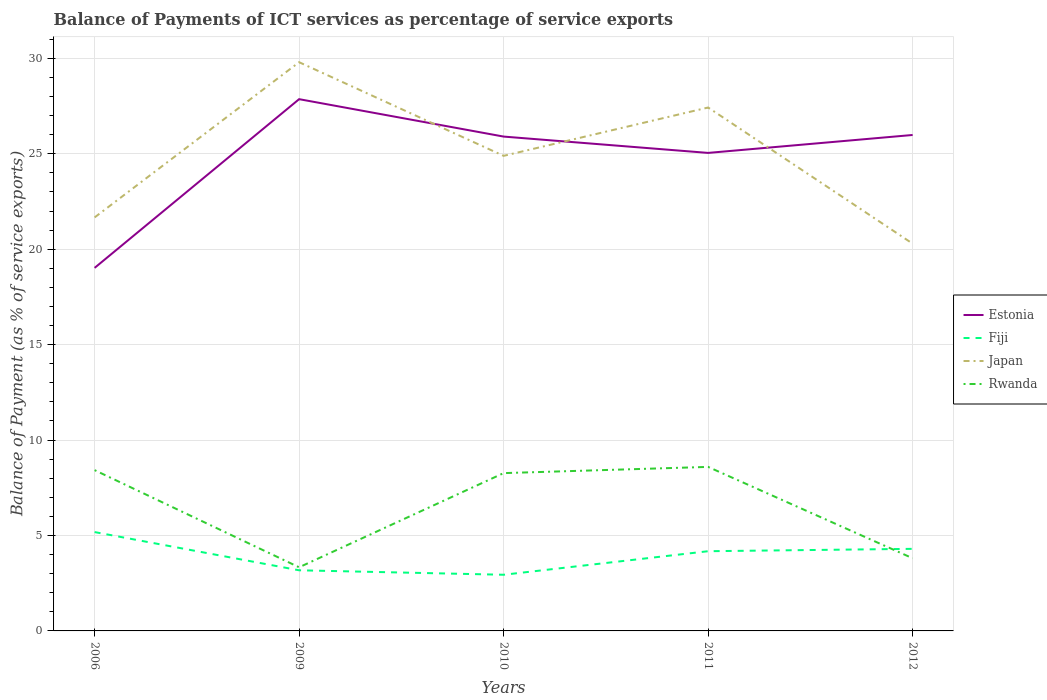Does the line corresponding to Estonia intersect with the line corresponding to Japan?
Provide a short and direct response. Yes. Across all years, what is the maximum balance of payments of ICT services in Japan?
Keep it short and to the point. 20.29. In which year was the balance of payments of ICT services in Japan maximum?
Give a very brief answer. 2012. What is the total balance of payments of ICT services in Rwanda in the graph?
Offer a very short reply. -4.93. What is the difference between the highest and the second highest balance of payments of ICT services in Rwanda?
Your answer should be very brief. 5.26. Is the balance of payments of ICT services in Japan strictly greater than the balance of payments of ICT services in Fiji over the years?
Your response must be concise. No. How many lines are there?
Your answer should be very brief. 4. How many years are there in the graph?
Ensure brevity in your answer.  5. What is the difference between two consecutive major ticks on the Y-axis?
Keep it short and to the point. 5. Are the values on the major ticks of Y-axis written in scientific E-notation?
Make the answer very short. No. Where does the legend appear in the graph?
Your answer should be compact. Center right. What is the title of the graph?
Give a very brief answer. Balance of Payments of ICT services as percentage of service exports. What is the label or title of the Y-axis?
Your answer should be very brief. Balance of Payment (as % of service exports). What is the Balance of Payment (as % of service exports) of Estonia in 2006?
Provide a short and direct response. 19.02. What is the Balance of Payment (as % of service exports) of Fiji in 2006?
Give a very brief answer. 5.18. What is the Balance of Payment (as % of service exports) of Japan in 2006?
Offer a terse response. 21.67. What is the Balance of Payment (as % of service exports) in Rwanda in 2006?
Ensure brevity in your answer.  8.42. What is the Balance of Payment (as % of service exports) of Estonia in 2009?
Provide a succinct answer. 27.86. What is the Balance of Payment (as % of service exports) of Fiji in 2009?
Provide a succinct answer. 3.18. What is the Balance of Payment (as % of service exports) in Japan in 2009?
Provide a short and direct response. 29.8. What is the Balance of Payment (as % of service exports) of Rwanda in 2009?
Make the answer very short. 3.33. What is the Balance of Payment (as % of service exports) in Estonia in 2010?
Make the answer very short. 25.9. What is the Balance of Payment (as % of service exports) in Fiji in 2010?
Your answer should be compact. 2.94. What is the Balance of Payment (as % of service exports) of Japan in 2010?
Provide a succinct answer. 24.89. What is the Balance of Payment (as % of service exports) of Rwanda in 2010?
Your answer should be very brief. 8.27. What is the Balance of Payment (as % of service exports) in Estonia in 2011?
Ensure brevity in your answer.  25.05. What is the Balance of Payment (as % of service exports) in Fiji in 2011?
Offer a very short reply. 4.18. What is the Balance of Payment (as % of service exports) in Japan in 2011?
Offer a very short reply. 27.42. What is the Balance of Payment (as % of service exports) of Rwanda in 2011?
Your answer should be very brief. 8.59. What is the Balance of Payment (as % of service exports) in Estonia in 2012?
Your answer should be very brief. 25.99. What is the Balance of Payment (as % of service exports) in Fiji in 2012?
Provide a short and direct response. 4.3. What is the Balance of Payment (as % of service exports) of Japan in 2012?
Your answer should be very brief. 20.29. What is the Balance of Payment (as % of service exports) of Rwanda in 2012?
Ensure brevity in your answer.  3.81. Across all years, what is the maximum Balance of Payment (as % of service exports) of Estonia?
Keep it short and to the point. 27.86. Across all years, what is the maximum Balance of Payment (as % of service exports) in Fiji?
Provide a succinct answer. 5.18. Across all years, what is the maximum Balance of Payment (as % of service exports) in Japan?
Your answer should be very brief. 29.8. Across all years, what is the maximum Balance of Payment (as % of service exports) of Rwanda?
Your answer should be very brief. 8.59. Across all years, what is the minimum Balance of Payment (as % of service exports) in Estonia?
Keep it short and to the point. 19.02. Across all years, what is the minimum Balance of Payment (as % of service exports) of Fiji?
Your answer should be compact. 2.94. Across all years, what is the minimum Balance of Payment (as % of service exports) in Japan?
Your answer should be very brief. 20.29. Across all years, what is the minimum Balance of Payment (as % of service exports) in Rwanda?
Provide a short and direct response. 3.33. What is the total Balance of Payment (as % of service exports) of Estonia in the graph?
Give a very brief answer. 123.82. What is the total Balance of Payment (as % of service exports) of Fiji in the graph?
Keep it short and to the point. 19.78. What is the total Balance of Payment (as % of service exports) in Japan in the graph?
Provide a short and direct response. 124.07. What is the total Balance of Payment (as % of service exports) of Rwanda in the graph?
Your answer should be compact. 32.43. What is the difference between the Balance of Payment (as % of service exports) in Estonia in 2006 and that in 2009?
Give a very brief answer. -8.84. What is the difference between the Balance of Payment (as % of service exports) in Fiji in 2006 and that in 2009?
Your response must be concise. 2. What is the difference between the Balance of Payment (as % of service exports) in Japan in 2006 and that in 2009?
Ensure brevity in your answer.  -8.13. What is the difference between the Balance of Payment (as % of service exports) in Rwanda in 2006 and that in 2009?
Offer a very short reply. 5.09. What is the difference between the Balance of Payment (as % of service exports) in Estonia in 2006 and that in 2010?
Make the answer very short. -6.88. What is the difference between the Balance of Payment (as % of service exports) of Fiji in 2006 and that in 2010?
Your response must be concise. 2.24. What is the difference between the Balance of Payment (as % of service exports) of Japan in 2006 and that in 2010?
Provide a succinct answer. -3.23. What is the difference between the Balance of Payment (as % of service exports) of Rwanda in 2006 and that in 2010?
Your answer should be compact. 0.16. What is the difference between the Balance of Payment (as % of service exports) in Estonia in 2006 and that in 2011?
Keep it short and to the point. -6.02. What is the difference between the Balance of Payment (as % of service exports) of Japan in 2006 and that in 2011?
Ensure brevity in your answer.  -5.76. What is the difference between the Balance of Payment (as % of service exports) of Rwanda in 2006 and that in 2011?
Offer a terse response. -0.17. What is the difference between the Balance of Payment (as % of service exports) of Estonia in 2006 and that in 2012?
Make the answer very short. -6.96. What is the difference between the Balance of Payment (as % of service exports) of Fiji in 2006 and that in 2012?
Make the answer very short. 0.88. What is the difference between the Balance of Payment (as % of service exports) in Japan in 2006 and that in 2012?
Ensure brevity in your answer.  1.37. What is the difference between the Balance of Payment (as % of service exports) of Rwanda in 2006 and that in 2012?
Your response must be concise. 4.62. What is the difference between the Balance of Payment (as % of service exports) of Estonia in 2009 and that in 2010?
Your response must be concise. 1.96. What is the difference between the Balance of Payment (as % of service exports) of Fiji in 2009 and that in 2010?
Your answer should be very brief. 0.23. What is the difference between the Balance of Payment (as % of service exports) of Japan in 2009 and that in 2010?
Keep it short and to the point. 4.91. What is the difference between the Balance of Payment (as % of service exports) in Rwanda in 2009 and that in 2010?
Offer a terse response. -4.93. What is the difference between the Balance of Payment (as % of service exports) of Estonia in 2009 and that in 2011?
Your answer should be very brief. 2.82. What is the difference between the Balance of Payment (as % of service exports) in Fiji in 2009 and that in 2011?
Offer a very short reply. -1. What is the difference between the Balance of Payment (as % of service exports) of Japan in 2009 and that in 2011?
Make the answer very short. 2.37. What is the difference between the Balance of Payment (as % of service exports) of Rwanda in 2009 and that in 2011?
Provide a succinct answer. -5.26. What is the difference between the Balance of Payment (as % of service exports) of Estonia in 2009 and that in 2012?
Ensure brevity in your answer.  1.88. What is the difference between the Balance of Payment (as % of service exports) of Fiji in 2009 and that in 2012?
Offer a terse response. -1.12. What is the difference between the Balance of Payment (as % of service exports) of Japan in 2009 and that in 2012?
Your response must be concise. 9.51. What is the difference between the Balance of Payment (as % of service exports) in Rwanda in 2009 and that in 2012?
Keep it short and to the point. -0.47. What is the difference between the Balance of Payment (as % of service exports) of Estonia in 2010 and that in 2011?
Your answer should be very brief. 0.86. What is the difference between the Balance of Payment (as % of service exports) in Fiji in 2010 and that in 2011?
Provide a short and direct response. -1.23. What is the difference between the Balance of Payment (as % of service exports) of Japan in 2010 and that in 2011?
Make the answer very short. -2.53. What is the difference between the Balance of Payment (as % of service exports) of Rwanda in 2010 and that in 2011?
Your answer should be very brief. -0.33. What is the difference between the Balance of Payment (as % of service exports) of Estonia in 2010 and that in 2012?
Provide a short and direct response. -0.08. What is the difference between the Balance of Payment (as % of service exports) in Fiji in 2010 and that in 2012?
Your answer should be compact. -1.36. What is the difference between the Balance of Payment (as % of service exports) of Japan in 2010 and that in 2012?
Ensure brevity in your answer.  4.6. What is the difference between the Balance of Payment (as % of service exports) in Rwanda in 2010 and that in 2012?
Offer a terse response. 4.46. What is the difference between the Balance of Payment (as % of service exports) in Estonia in 2011 and that in 2012?
Your answer should be compact. -0.94. What is the difference between the Balance of Payment (as % of service exports) in Fiji in 2011 and that in 2012?
Make the answer very short. -0.12. What is the difference between the Balance of Payment (as % of service exports) in Japan in 2011 and that in 2012?
Provide a succinct answer. 7.13. What is the difference between the Balance of Payment (as % of service exports) of Rwanda in 2011 and that in 2012?
Give a very brief answer. 4.79. What is the difference between the Balance of Payment (as % of service exports) of Estonia in 2006 and the Balance of Payment (as % of service exports) of Fiji in 2009?
Offer a terse response. 15.84. What is the difference between the Balance of Payment (as % of service exports) of Estonia in 2006 and the Balance of Payment (as % of service exports) of Japan in 2009?
Your answer should be compact. -10.78. What is the difference between the Balance of Payment (as % of service exports) of Estonia in 2006 and the Balance of Payment (as % of service exports) of Rwanda in 2009?
Your answer should be very brief. 15.69. What is the difference between the Balance of Payment (as % of service exports) in Fiji in 2006 and the Balance of Payment (as % of service exports) in Japan in 2009?
Provide a short and direct response. -24.62. What is the difference between the Balance of Payment (as % of service exports) in Fiji in 2006 and the Balance of Payment (as % of service exports) in Rwanda in 2009?
Make the answer very short. 1.84. What is the difference between the Balance of Payment (as % of service exports) of Japan in 2006 and the Balance of Payment (as % of service exports) of Rwanda in 2009?
Offer a terse response. 18.33. What is the difference between the Balance of Payment (as % of service exports) of Estonia in 2006 and the Balance of Payment (as % of service exports) of Fiji in 2010?
Your answer should be very brief. 16.08. What is the difference between the Balance of Payment (as % of service exports) in Estonia in 2006 and the Balance of Payment (as % of service exports) in Japan in 2010?
Provide a succinct answer. -5.87. What is the difference between the Balance of Payment (as % of service exports) in Estonia in 2006 and the Balance of Payment (as % of service exports) in Rwanda in 2010?
Make the answer very short. 10.75. What is the difference between the Balance of Payment (as % of service exports) of Fiji in 2006 and the Balance of Payment (as % of service exports) of Japan in 2010?
Offer a terse response. -19.71. What is the difference between the Balance of Payment (as % of service exports) in Fiji in 2006 and the Balance of Payment (as % of service exports) in Rwanda in 2010?
Offer a terse response. -3.09. What is the difference between the Balance of Payment (as % of service exports) in Japan in 2006 and the Balance of Payment (as % of service exports) in Rwanda in 2010?
Your answer should be compact. 13.4. What is the difference between the Balance of Payment (as % of service exports) in Estonia in 2006 and the Balance of Payment (as % of service exports) in Fiji in 2011?
Keep it short and to the point. 14.84. What is the difference between the Balance of Payment (as % of service exports) in Estonia in 2006 and the Balance of Payment (as % of service exports) in Japan in 2011?
Provide a short and direct response. -8.4. What is the difference between the Balance of Payment (as % of service exports) in Estonia in 2006 and the Balance of Payment (as % of service exports) in Rwanda in 2011?
Provide a succinct answer. 10.43. What is the difference between the Balance of Payment (as % of service exports) of Fiji in 2006 and the Balance of Payment (as % of service exports) of Japan in 2011?
Offer a terse response. -22.25. What is the difference between the Balance of Payment (as % of service exports) of Fiji in 2006 and the Balance of Payment (as % of service exports) of Rwanda in 2011?
Your answer should be very brief. -3.42. What is the difference between the Balance of Payment (as % of service exports) in Japan in 2006 and the Balance of Payment (as % of service exports) in Rwanda in 2011?
Make the answer very short. 13.07. What is the difference between the Balance of Payment (as % of service exports) of Estonia in 2006 and the Balance of Payment (as % of service exports) of Fiji in 2012?
Your answer should be very brief. 14.72. What is the difference between the Balance of Payment (as % of service exports) of Estonia in 2006 and the Balance of Payment (as % of service exports) of Japan in 2012?
Keep it short and to the point. -1.27. What is the difference between the Balance of Payment (as % of service exports) of Estonia in 2006 and the Balance of Payment (as % of service exports) of Rwanda in 2012?
Your answer should be compact. 15.21. What is the difference between the Balance of Payment (as % of service exports) of Fiji in 2006 and the Balance of Payment (as % of service exports) of Japan in 2012?
Offer a very short reply. -15.11. What is the difference between the Balance of Payment (as % of service exports) in Fiji in 2006 and the Balance of Payment (as % of service exports) in Rwanda in 2012?
Provide a succinct answer. 1.37. What is the difference between the Balance of Payment (as % of service exports) of Japan in 2006 and the Balance of Payment (as % of service exports) of Rwanda in 2012?
Ensure brevity in your answer.  17.86. What is the difference between the Balance of Payment (as % of service exports) in Estonia in 2009 and the Balance of Payment (as % of service exports) in Fiji in 2010?
Ensure brevity in your answer.  24.92. What is the difference between the Balance of Payment (as % of service exports) in Estonia in 2009 and the Balance of Payment (as % of service exports) in Japan in 2010?
Your response must be concise. 2.97. What is the difference between the Balance of Payment (as % of service exports) of Estonia in 2009 and the Balance of Payment (as % of service exports) of Rwanda in 2010?
Offer a very short reply. 19.59. What is the difference between the Balance of Payment (as % of service exports) in Fiji in 2009 and the Balance of Payment (as % of service exports) in Japan in 2010?
Give a very brief answer. -21.71. What is the difference between the Balance of Payment (as % of service exports) of Fiji in 2009 and the Balance of Payment (as % of service exports) of Rwanda in 2010?
Ensure brevity in your answer.  -5.09. What is the difference between the Balance of Payment (as % of service exports) in Japan in 2009 and the Balance of Payment (as % of service exports) in Rwanda in 2010?
Your answer should be very brief. 21.53. What is the difference between the Balance of Payment (as % of service exports) in Estonia in 2009 and the Balance of Payment (as % of service exports) in Fiji in 2011?
Keep it short and to the point. 23.68. What is the difference between the Balance of Payment (as % of service exports) in Estonia in 2009 and the Balance of Payment (as % of service exports) in Japan in 2011?
Provide a short and direct response. 0.44. What is the difference between the Balance of Payment (as % of service exports) of Estonia in 2009 and the Balance of Payment (as % of service exports) of Rwanda in 2011?
Offer a terse response. 19.27. What is the difference between the Balance of Payment (as % of service exports) in Fiji in 2009 and the Balance of Payment (as % of service exports) in Japan in 2011?
Provide a succinct answer. -24.25. What is the difference between the Balance of Payment (as % of service exports) of Fiji in 2009 and the Balance of Payment (as % of service exports) of Rwanda in 2011?
Ensure brevity in your answer.  -5.42. What is the difference between the Balance of Payment (as % of service exports) of Japan in 2009 and the Balance of Payment (as % of service exports) of Rwanda in 2011?
Your response must be concise. 21.2. What is the difference between the Balance of Payment (as % of service exports) in Estonia in 2009 and the Balance of Payment (as % of service exports) in Fiji in 2012?
Offer a very short reply. 23.56. What is the difference between the Balance of Payment (as % of service exports) of Estonia in 2009 and the Balance of Payment (as % of service exports) of Japan in 2012?
Your answer should be very brief. 7.57. What is the difference between the Balance of Payment (as % of service exports) in Estonia in 2009 and the Balance of Payment (as % of service exports) in Rwanda in 2012?
Give a very brief answer. 24.05. What is the difference between the Balance of Payment (as % of service exports) in Fiji in 2009 and the Balance of Payment (as % of service exports) in Japan in 2012?
Offer a terse response. -17.12. What is the difference between the Balance of Payment (as % of service exports) of Fiji in 2009 and the Balance of Payment (as % of service exports) of Rwanda in 2012?
Make the answer very short. -0.63. What is the difference between the Balance of Payment (as % of service exports) in Japan in 2009 and the Balance of Payment (as % of service exports) in Rwanda in 2012?
Keep it short and to the point. 25.99. What is the difference between the Balance of Payment (as % of service exports) in Estonia in 2010 and the Balance of Payment (as % of service exports) in Fiji in 2011?
Give a very brief answer. 21.72. What is the difference between the Balance of Payment (as % of service exports) in Estonia in 2010 and the Balance of Payment (as % of service exports) in Japan in 2011?
Keep it short and to the point. -1.52. What is the difference between the Balance of Payment (as % of service exports) of Estonia in 2010 and the Balance of Payment (as % of service exports) of Rwanda in 2011?
Your response must be concise. 17.31. What is the difference between the Balance of Payment (as % of service exports) of Fiji in 2010 and the Balance of Payment (as % of service exports) of Japan in 2011?
Your response must be concise. -24.48. What is the difference between the Balance of Payment (as % of service exports) of Fiji in 2010 and the Balance of Payment (as % of service exports) of Rwanda in 2011?
Provide a succinct answer. -5.65. What is the difference between the Balance of Payment (as % of service exports) of Japan in 2010 and the Balance of Payment (as % of service exports) of Rwanda in 2011?
Give a very brief answer. 16.3. What is the difference between the Balance of Payment (as % of service exports) of Estonia in 2010 and the Balance of Payment (as % of service exports) of Fiji in 2012?
Your answer should be very brief. 21.6. What is the difference between the Balance of Payment (as % of service exports) of Estonia in 2010 and the Balance of Payment (as % of service exports) of Japan in 2012?
Offer a very short reply. 5.61. What is the difference between the Balance of Payment (as % of service exports) of Estonia in 2010 and the Balance of Payment (as % of service exports) of Rwanda in 2012?
Provide a short and direct response. 22.09. What is the difference between the Balance of Payment (as % of service exports) in Fiji in 2010 and the Balance of Payment (as % of service exports) in Japan in 2012?
Your answer should be very brief. -17.35. What is the difference between the Balance of Payment (as % of service exports) of Fiji in 2010 and the Balance of Payment (as % of service exports) of Rwanda in 2012?
Provide a succinct answer. -0.86. What is the difference between the Balance of Payment (as % of service exports) in Japan in 2010 and the Balance of Payment (as % of service exports) in Rwanda in 2012?
Your answer should be compact. 21.08. What is the difference between the Balance of Payment (as % of service exports) of Estonia in 2011 and the Balance of Payment (as % of service exports) of Fiji in 2012?
Provide a succinct answer. 20.75. What is the difference between the Balance of Payment (as % of service exports) of Estonia in 2011 and the Balance of Payment (as % of service exports) of Japan in 2012?
Provide a succinct answer. 4.75. What is the difference between the Balance of Payment (as % of service exports) of Estonia in 2011 and the Balance of Payment (as % of service exports) of Rwanda in 2012?
Offer a very short reply. 21.24. What is the difference between the Balance of Payment (as % of service exports) in Fiji in 2011 and the Balance of Payment (as % of service exports) in Japan in 2012?
Offer a very short reply. -16.12. What is the difference between the Balance of Payment (as % of service exports) in Fiji in 2011 and the Balance of Payment (as % of service exports) in Rwanda in 2012?
Offer a terse response. 0.37. What is the difference between the Balance of Payment (as % of service exports) in Japan in 2011 and the Balance of Payment (as % of service exports) in Rwanda in 2012?
Your answer should be compact. 23.62. What is the average Balance of Payment (as % of service exports) of Estonia per year?
Offer a terse response. 24.76. What is the average Balance of Payment (as % of service exports) of Fiji per year?
Provide a short and direct response. 3.96. What is the average Balance of Payment (as % of service exports) in Japan per year?
Make the answer very short. 24.81. What is the average Balance of Payment (as % of service exports) of Rwanda per year?
Offer a very short reply. 6.49. In the year 2006, what is the difference between the Balance of Payment (as % of service exports) of Estonia and Balance of Payment (as % of service exports) of Fiji?
Offer a very short reply. 13.84. In the year 2006, what is the difference between the Balance of Payment (as % of service exports) in Estonia and Balance of Payment (as % of service exports) in Japan?
Your answer should be compact. -2.65. In the year 2006, what is the difference between the Balance of Payment (as % of service exports) in Estonia and Balance of Payment (as % of service exports) in Rwanda?
Ensure brevity in your answer.  10.6. In the year 2006, what is the difference between the Balance of Payment (as % of service exports) in Fiji and Balance of Payment (as % of service exports) in Japan?
Provide a short and direct response. -16.49. In the year 2006, what is the difference between the Balance of Payment (as % of service exports) of Fiji and Balance of Payment (as % of service exports) of Rwanda?
Offer a terse response. -3.25. In the year 2006, what is the difference between the Balance of Payment (as % of service exports) of Japan and Balance of Payment (as % of service exports) of Rwanda?
Make the answer very short. 13.24. In the year 2009, what is the difference between the Balance of Payment (as % of service exports) of Estonia and Balance of Payment (as % of service exports) of Fiji?
Offer a very short reply. 24.68. In the year 2009, what is the difference between the Balance of Payment (as % of service exports) in Estonia and Balance of Payment (as % of service exports) in Japan?
Offer a terse response. -1.94. In the year 2009, what is the difference between the Balance of Payment (as % of service exports) in Estonia and Balance of Payment (as % of service exports) in Rwanda?
Your response must be concise. 24.53. In the year 2009, what is the difference between the Balance of Payment (as % of service exports) in Fiji and Balance of Payment (as % of service exports) in Japan?
Offer a terse response. -26.62. In the year 2009, what is the difference between the Balance of Payment (as % of service exports) in Fiji and Balance of Payment (as % of service exports) in Rwanda?
Make the answer very short. -0.16. In the year 2009, what is the difference between the Balance of Payment (as % of service exports) of Japan and Balance of Payment (as % of service exports) of Rwanda?
Your response must be concise. 26.46. In the year 2010, what is the difference between the Balance of Payment (as % of service exports) of Estonia and Balance of Payment (as % of service exports) of Fiji?
Provide a short and direct response. 22.96. In the year 2010, what is the difference between the Balance of Payment (as % of service exports) of Estonia and Balance of Payment (as % of service exports) of Japan?
Give a very brief answer. 1.01. In the year 2010, what is the difference between the Balance of Payment (as % of service exports) of Estonia and Balance of Payment (as % of service exports) of Rwanda?
Your answer should be compact. 17.63. In the year 2010, what is the difference between the Balance of Payment (as % of service exports) in Fiji and Balance of Payment (as % of service exports) in Japan?
Keep it short and to the point. -21.95. In the year 2010, what is the difference between the Balance of Payment (as % of service exports) in Fiji and Balance of Payment (as % of service exports) in Rwanda?
Your answer should be very brief. -5.33. In the year 2010, what is the difference between the Balance of Payment (as % of service exports) in Japan and Balance of Payment (as % of service exports) in Rwanda?
Make the answer very short. 16.62. In the year 2011, what is the difference between the Balance of Payment (as % of service exports) of Estonia and Balance of Payment (as % of service exports) of Fiji?
Your answer should be compact. 20.87. In the year 2011, what is the difference between the Balance of Payment (as % of service exports) in Estonia and Balance of Payment (as % of service exports) in Japan?
Your response must be concise. -2.38. In the year 2011, what is the difference between the Balance of Payment (as % of service exports) of Estonia and Balance of Payment (as % of service exports) of Rwanda?
Keep it short and to the point. 16.45. In the year 2011, what is the difference between the Balance of Payment (as % of service exports) of Fiji and Balance of Payment (as % of service exports) of Japan?
Offer a terse response. -23.25. In the year 2011, what is the difference between the Balance of Payment (as % of service exports) of Fiji and Balance of Payment (as % of service exports) of Rwanda?
Your answer should be very brief. -4.42. In the year 2011, what is the difference between the Balance of Payment (as % of service exports) in Japan and Balance of Payment (as % of service exports) in Rwanda?
Provide a succinct answer. 18.83. In the year 2012, what is the difference between the Balance of Payment (as % of service exports) in Estonia and Balance of Payment (as % of service exports) in Fiji?
Offer a terse response. 21.68. In the year 2012, what is the difference between the Balance of Payment (as % of service exports) of Estonia and Balance of Payment (as % of service exports) of Japan?
Provide a succinct answer. 5.69. In the year 2012, what is the difference between the Balance of Payment (as % of service exports) of Estonia and Balance of Payment (as % of service exports) of Rwanda?
Offer a very short reply. 22.18. In the year 2012, what is the difference between the Balance of Payment (as % of service exports) in Fiji and Balance of Payment (as % of service exports) in Japan?
Give a very brief answer. -15.99. In the year 2012, what is the difference between the Balance of Payment (as % of service exports) of Fiji and Balance of Payment (as % of service exports) of Rwanda?
Offer a very short reply. 0.49. In the year 2012, what is the difference between the Balance of Payment (as % of service exports) in Japan and Balance of Payment (as % of service exports) in Rwanda?
Ensure brevity in your answer.  16.48. What is the ratio of the Balance of Payment (as % of service exports) of Estonia in 2006 to that in 2009?
Provide a succinct answer. 0.68. What is the ratio of the Balance of Payment (as % of service exports) in Fiji in 2006 to that in 2009?
Offer a very short reply. 1.63. What is the ratio of the Balance of Payment (as % of service exports) in Japan in 2006 to that in 2009?
Provide a short and direct response. 0.73. What is the ratio of the Balance of Payment (as % of service exports) of Rwanda in 2006 to that in 2009?
Keep it short and to the point. 2.53. What is the ratio of the Balance of Payment (as % of service exports) of Estonia in 2006 to that in 2010?
Your answer should be compact. 0.73. What is the ratio of the Balance of Payment (as % of service exports) in Fiji in 2006 to that in 2010?
Provide a short and direct response. 1.76. What is the ratio of the Balance of Payment (as % of service exports) in Japan in 2006 to that in 2010?
Keep it short and to the point. 0.87. What is the ratio of the Balance of Payment (as % of service exports) of Rwanda in 2006 to that in 2010?
Your response must be concise. 1.02. What is the ratio of the Balance of Payment (as % of service exports) of Estonia in 2006 to that in 2011?
Your answer should be compact. 0.76. What is the ratio of the Balance of Payment (as % of service exports) in Fiji in 2006 to that in 2011?
Your response must be concise. 1.24. What is the ratio of the Balance of Payment (as % of service exports) of Japan in 2006 to that in 2011?
Provide a succinct answer. 0.79. What is the ratio of the Balance of Payment (as % of service exports) of Rwanda in 2006 to that in 2011?
Your answer should be compact. 0.98. What is the ratio of the Balance of Payment (as % of service exports) in Estonia in 2006 to that in 2012?
Ensure brevity in your answer.  0.73. What is the ratio of the Balance of Payment (as % of service exports) in Fiji in 2006 to that in 2012?
Your response must be concise. 1.2. What is the ratio of the Balance of Payment (as % of service exports) in Japan in 2006 to that in 2012?
Provide a short and direct response. 1.07. What is the ratio of the Balance of Payment (as % of service exports) in Rwanda in 2006 to that in 2012?
Provide a succinct answer. 2.21. What is the ratio of the Balance of Payment (as % of service exports) in Estonia in 2009 to that in 2010?
Make the answer very short. 1.08. What is the ratio of the Balance of Payment (as % of service exports) in Fiji in 2009 to that in 2010?
Make the answer very short. 1.08. What is the ratio of the Balance of Payment (as % of service exports) in Japan in 2009 to that in 2010?
Give a very brief answer. 1.2. What is the ratio of the Balance of Payment (as % of service exports) in Rwanda in 2009 to that in 2010?
Make the answer very short. 0.4. What is the ratio of the Balance of Payment (as % of service exports) of Estonia in 2009 to that in 2011?
Ensure brevity in your answer.  1.11. What is the ratio of the Balance of Payment (as % of service exports) in Fiji in 2009 to that in 2011?
Your answer should be very brief. 0.76. What is the ratio of the Balance of Payment (as % of service exports) in Japan in 2009 to that in 2011?
Ensure brevity in your answer.  1.09. What is the ratio of the Balance of Payment (as % of service exports) in Rwanda in 2009 to that in 2011?
Give a very brief answer. 0.39. What is the ratio of the Balance of Payment (as % of service exports) in Estonia in 2009 to that in 2012?
Offer a very short reply. 1.07. What is the ratio of the Balance of Payment (as % of service exports) in Fiji in 2009 to that in 2012?
Keep it short and to the point. 0.74. What is the ratio of the Balance of Payment (as % of service exports) in Japan in 2009 to that in 2012?
Your response must be concise. 1.47. What is the ratio of the Balance of Payment (as % of service exports) of Rwanda in 2009 to that in 2012?
Keep it short and to the point. 0.88. What is the ratio of the Balance of Payment (as % of service exports) of Estonia in 2010 to that in 2011?
Keep it short and to the point. 1.03. What is the ratio of the Balance of Payment (as % of service exports) in Fiji in 2010 to that in 2011?
Keep it short and to the point. 0.7. What is the ratio of the Balance of Payment (as % of service exports) in Japan in 2010 to that in 2011?
Provide a succinct answer. 0.91. What is the ratio of the Balance of Payment (as % of service exports) of Rwanda in 2010 to that in 2011?
Give a very brief answer. 0.96. What is the ratio of the Balance of Payment (as % of service exports) in Fiji in 2010 to that in 2012?
Keep it short and to the point. 0.68. What is the ratio of the Balance of Payment (as % of service exports) in Japan in 2010 to that in 2012?
Provide a short and direct response. 1.23. What is the ratio of the Balance of Payment (as % of service exports) of Rwanda in 2010 to that in 2012?
Your response must be concise. 2.17. What is the ratio of the Balance of Payment (as % of service exports) in Estonia in 2011 to that in 2012?
Your answer should be compact. 0.96. What is the ratio of the Balance of Payment (as % of service exports) in Fiji in 2011 to that in 2012?
Give a very brief answer. 0.97. What is the ratio of the Balance of Payment (as % of service exports) in Japan in 2011 to that in 2012?
Your response must be concise. 1.35. What is the ratio of the Balance of Payment (as % of service exports) of Rwanda in 2011 to that in 2012?
Offer a very short reply. 2.26. What is the difference between the highest and the second highest Balance of Payment (as % of service exports) in Estonia?
Give a very brief answer. 1.88. What is the difference between the highest and the second highest Balance of Payment (as % of service exports) in Fiji?
Ensure brevity in your answer.  0.88. What is the difference between the highest and the second highest Balance of Payment (as % of service exports) in Japan?
Your response must be concise. 2.37. What is the difference between the highest and the second highest Balance of Payment (as % of service exports) of Rwanda?
Provide a succinct answer. 0.17. What is the difference between the highest and the lowest Balance of Payment (as % of service exports) in Estonia?
Give a very brief answer. 8.84. What is the difference between the highest and the lowest Balance of Payment (as % of service exports) in Fiji?
Make the answer very short. 2.24. What is the difference between the highest and the lowest Balance of Payment (as % of service exports) of Japan?
Provide a succinct answer. 9.51. What is the difference between the highest and the lowest Balance of Payment (as % of service exports) in Rwanda?
Provide a short and direct response. 5.26. 